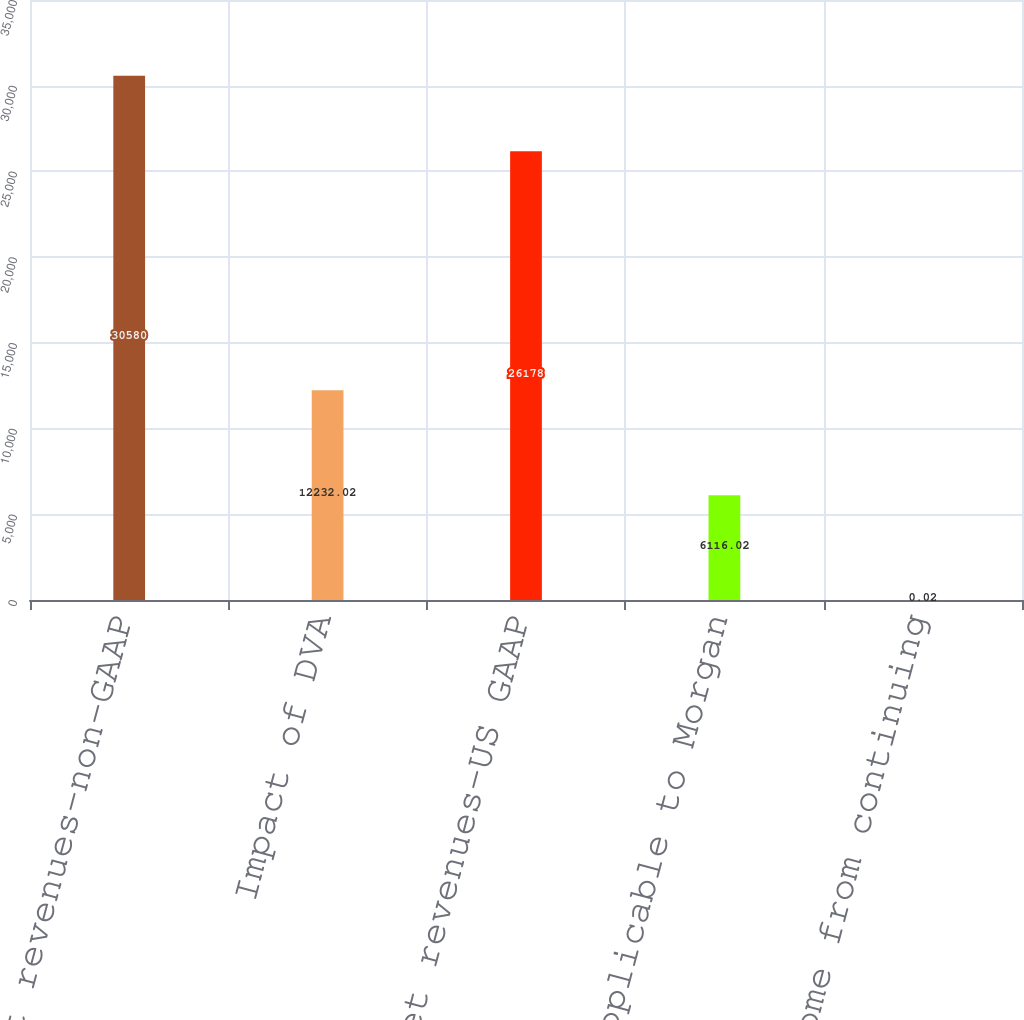<chart> <loc_0><loc_0><loc_500><loc_500><bar_chart><fcel>Net revenues-non-GAAP<fcel>Impact of DVA<fcel>Net revenues-US GAAP<fcel>Income applicable to Morgan<fcel>Income from continuing<nl><fcel>30580<fcel>12232<fcel>26178<fcel>6116.02<fcel>0.02<nl></chart> 